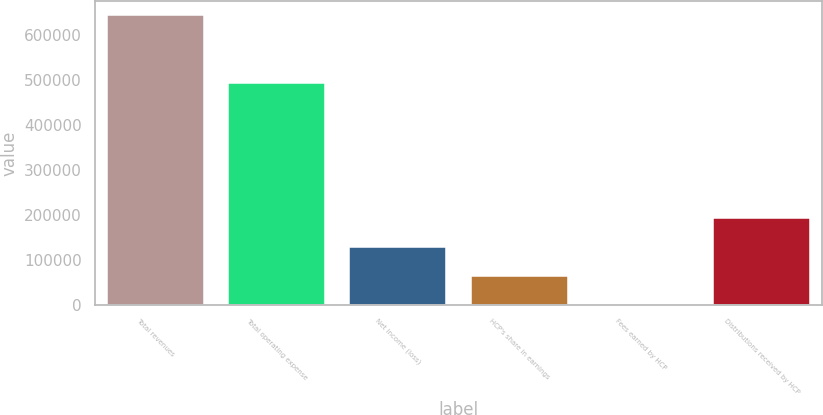<chart> <loc_0><loc_0><loc_500><loc_500><bar_chart><fcel>Total revenues<fcel>Total operating expense<fcel>Net income (loss)<fcel>HCP's share in earnings<fcel>Fees earned by HCP<fcel>Distributions received by HCP<nl><fcel>642724<fcel>492784<fcel>128645<fcel>64384.9<fcel>125<fcel>192905<nl></chart> 